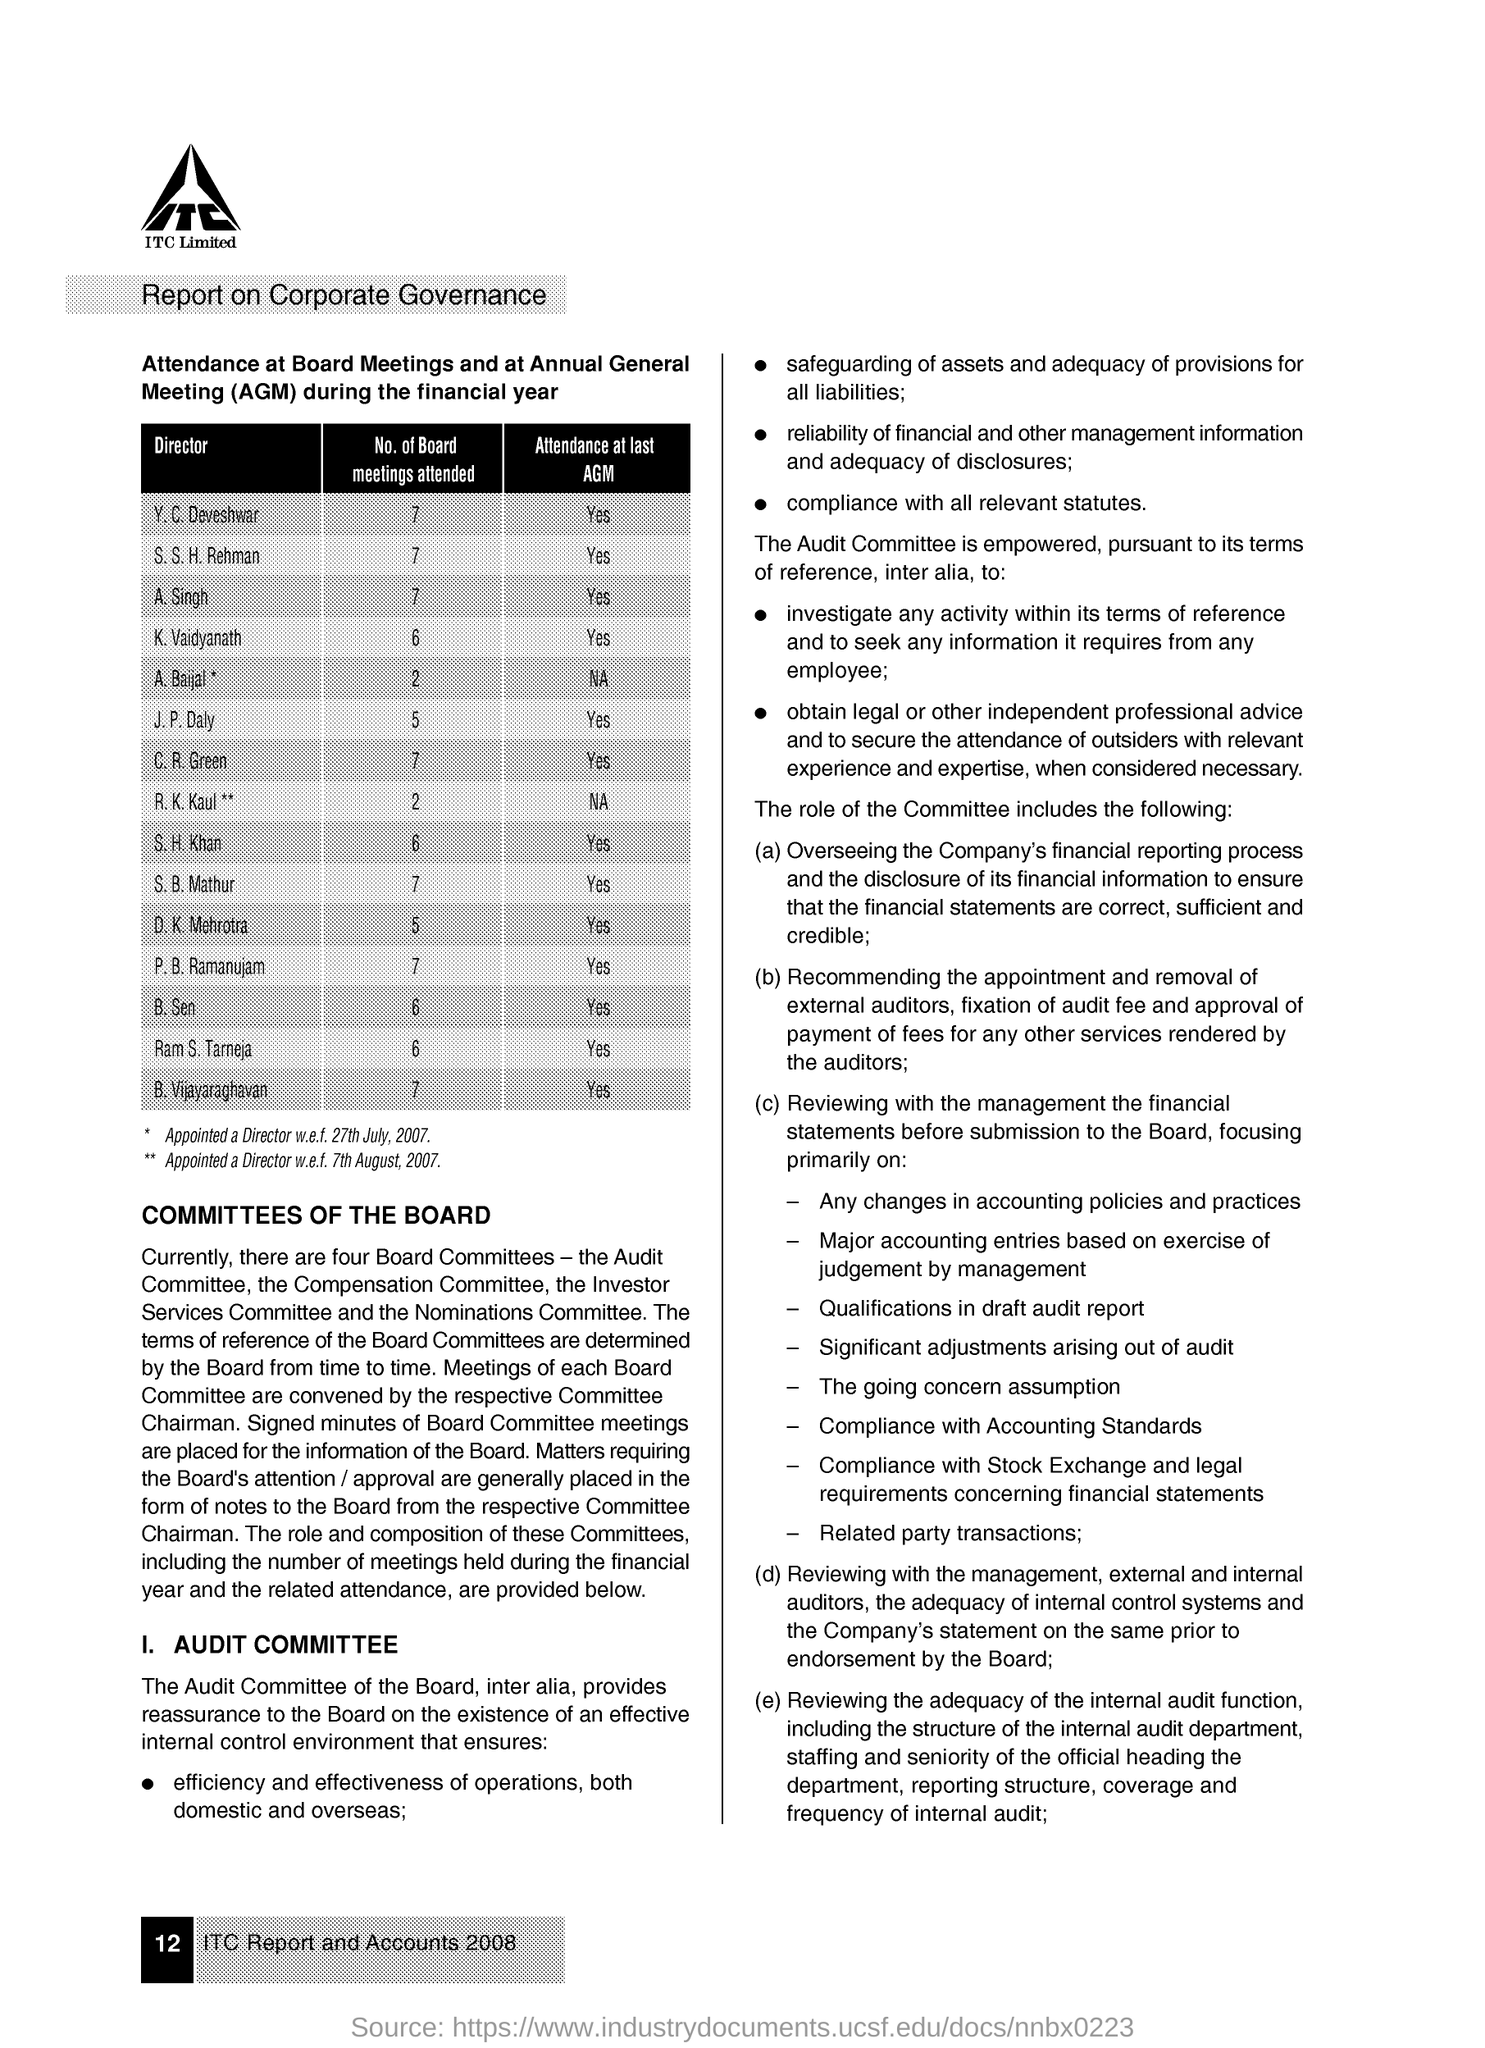What are the No. of Board meetings attented by Y. C. Deveshwar?
Offer a terse response. 7. What are the No. of Board meetings attented by A. Singh?
Make the answer very short. 7. What are the No. of Board meetings attented by K. Vaidyanath?
Ensure brevity in your answer.  6. What are the No. of Board meetings attented by B. Sen?
Your answer should be very brief. 6. What are the No. of Board meetings attented by R. K. Kaul?
Offer a terse response. 2. What are the No. of Board meetings attented by C. R. Green?
Your answer should be compact. 7. What are the No. of Board meetings attented by S. H. Khan?
Make the answer very short. 6. What are the No. of Board meetings attented by S. B. Mathur?
Offer a terse response. 7. 